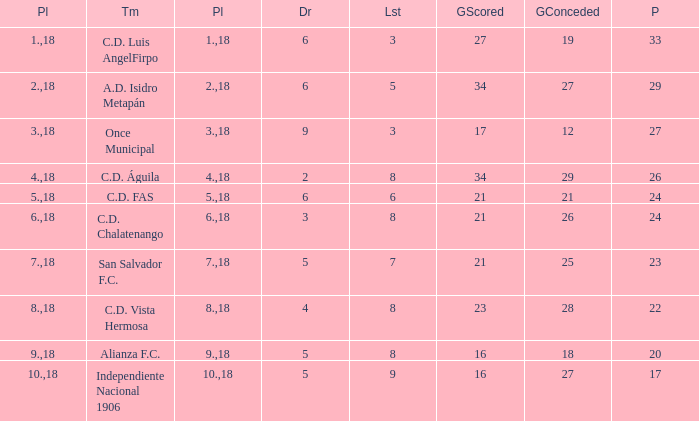What's the place that Once Municipal has a lost greater than 3? None. 